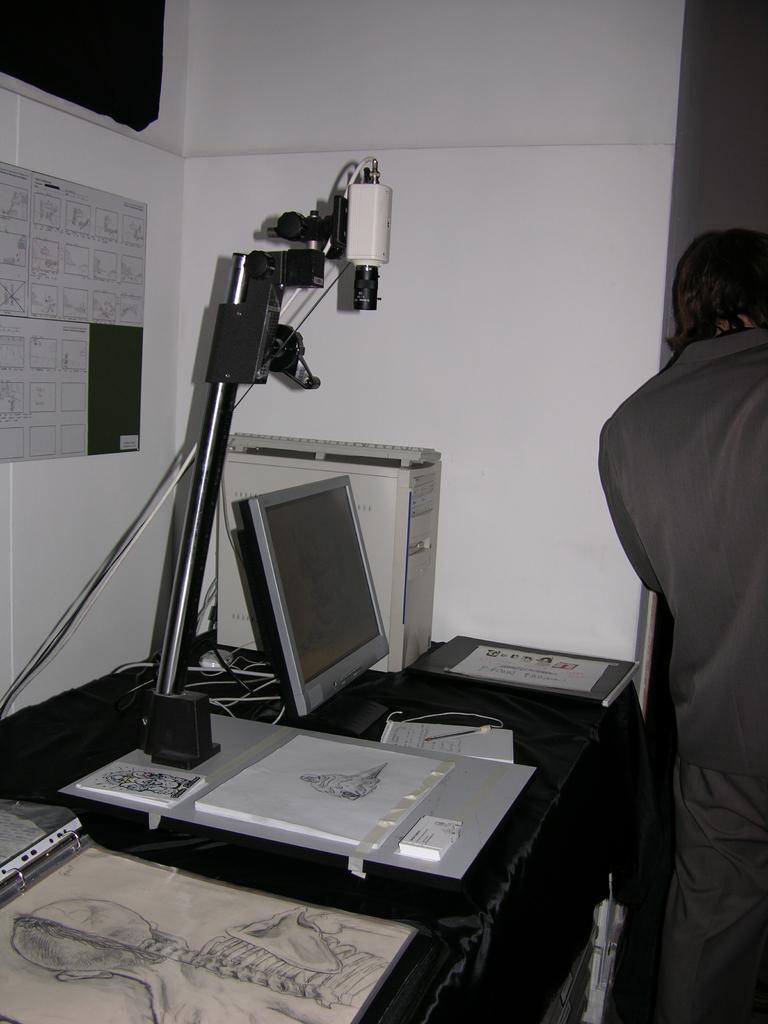Describe this image in one or two sentences. In this image we can see a system, keyboard, a white color object, few papers and few other objects on the table and a person standing near the table and a poster to the wall. 